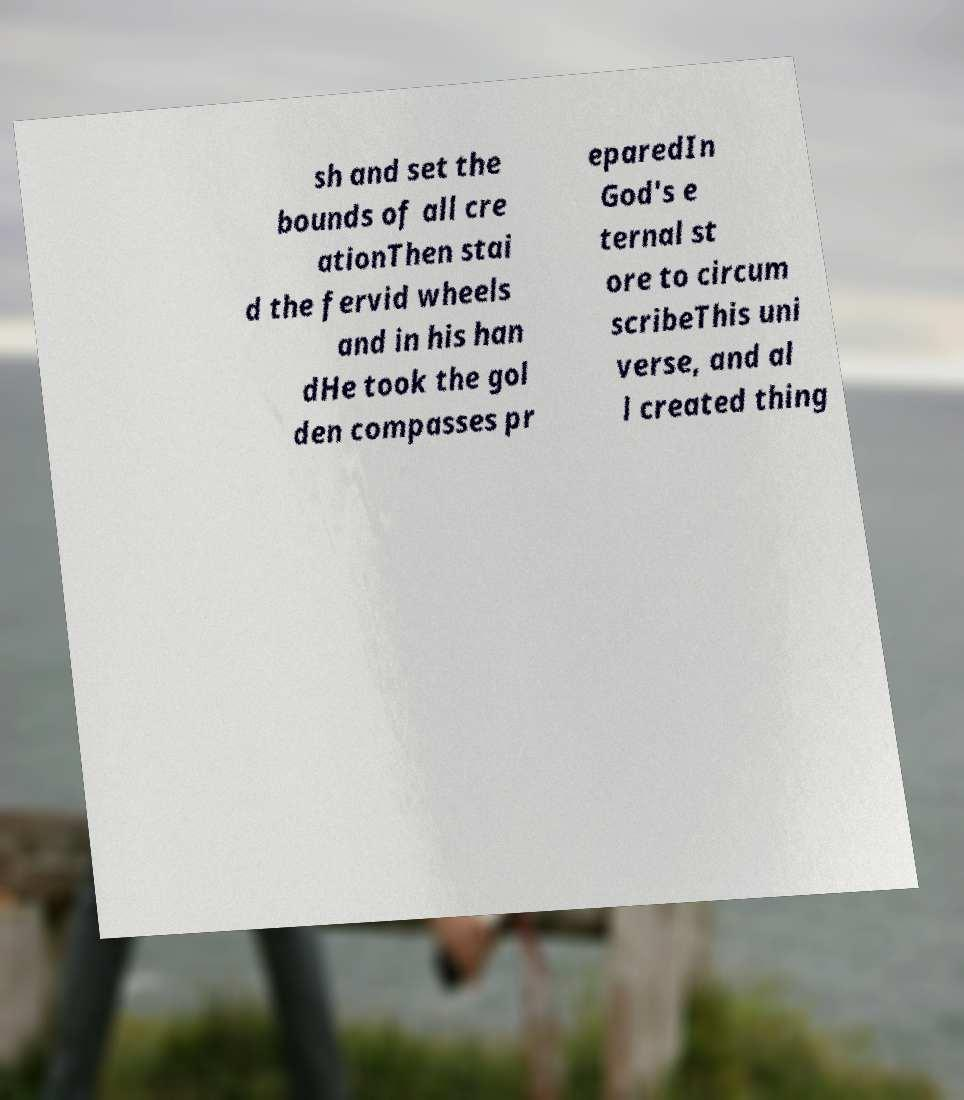I need the written content from this picture converted into text. Can you do that? sh and set the bounds of all cre ationThen stai d the fervid wheels and in his han dHe took the gol den compasses pr eparedIn God's e ternal st ore to circum scribeThis uni verse, and al l created thing 